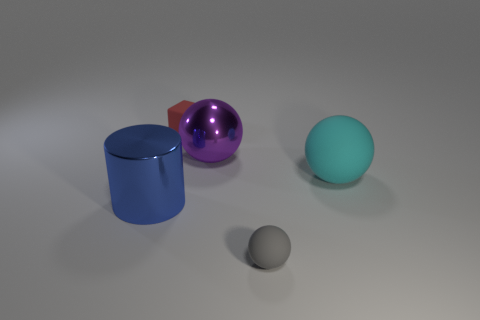Subtract all matte balls. How many balls are left? 1 Add 1 big blue objects. How many objects exist? 6 Subtract all gray spheres. How many spheres are left? 2 Subtract all blocks. How many objects are left? 4 Subtract 1 cubes. How many cubes are left? 0 Add 3 purple things. How many purple things exist? 4 Subtract 1 red blocks. How many objects are left? 4 Subtract all cyan spheres. Subtract all green cylinders. How many spheres are left? 2 Subtract all blue cylinders. How many red spheres are left? 0 Subtract all gray spheres. Subtract all yellow blocks. How many objects are left? 4 